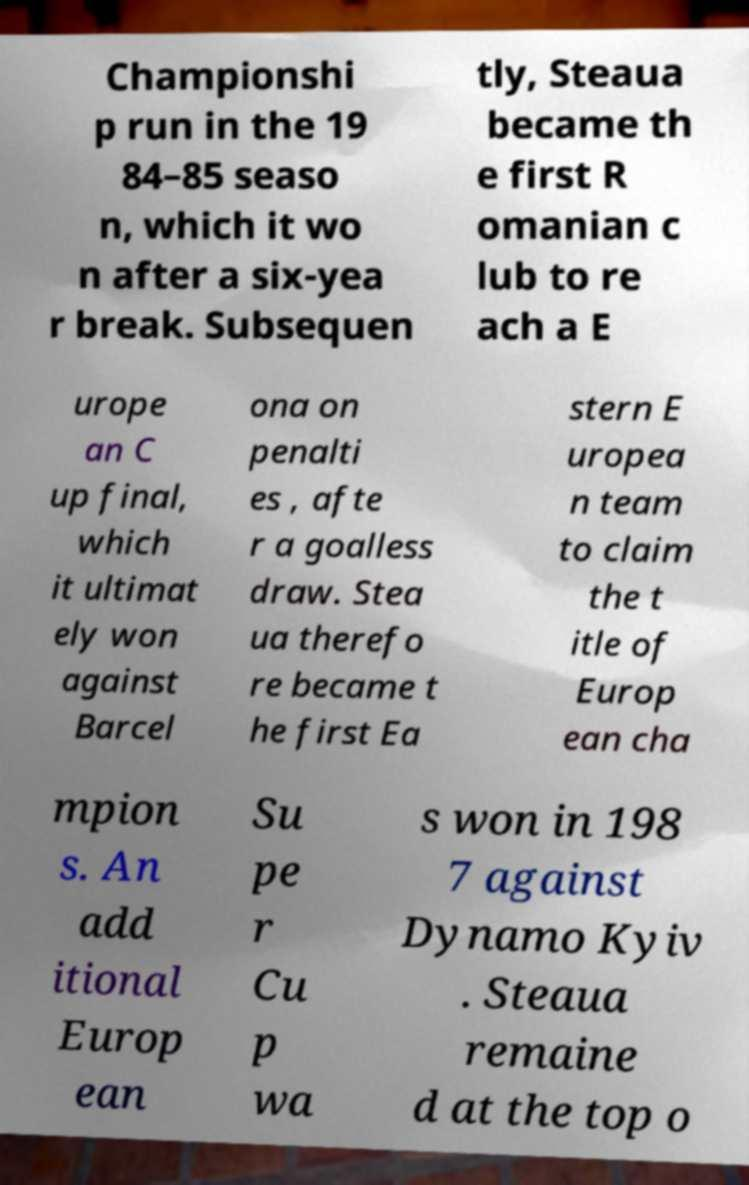Please read and relay the text visible in this image. What does it say? Championshi p run in the 19 84–85 seaso n, which it wo n after a six-yea r break. Subsequen tly, Steaua became th e first R omanian c lub to re ach a E urope an C up final, which it ultimat ely won against Barcel ona on penalti es , afte r a goalless draw. Stea ua therefo re became t he first Ea stern E uropea n team to claim the t itle of Europ ean cha mpion s. An add itional Europ ean Su pe r Cu p wa s won in 198 7 against Dynamo Kyiv . Steaua remaine d at the top o 